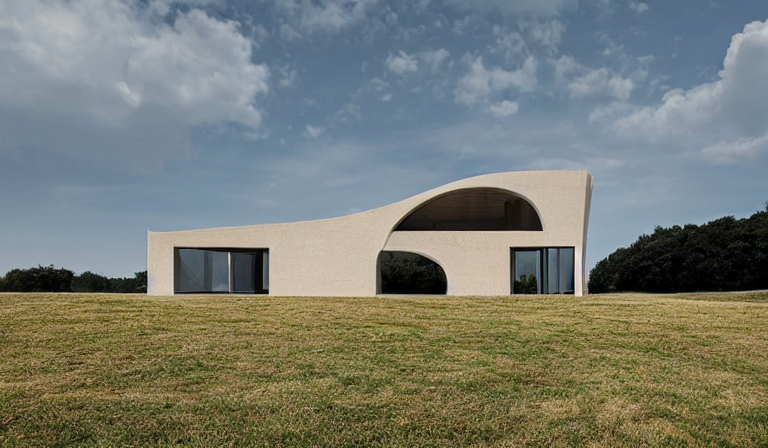What architectural style does this building represent? The building features a modern architectural style with minimalist lines, sweeping curves, and large windows that embrace natural light, aiming for a seamless integration with the surrounding landscape. 